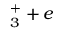Convert formula to latex. <formula><loc_0><loc_0><loc_500><loc_500>_ { 3 } ^ { + } + e</formula> 